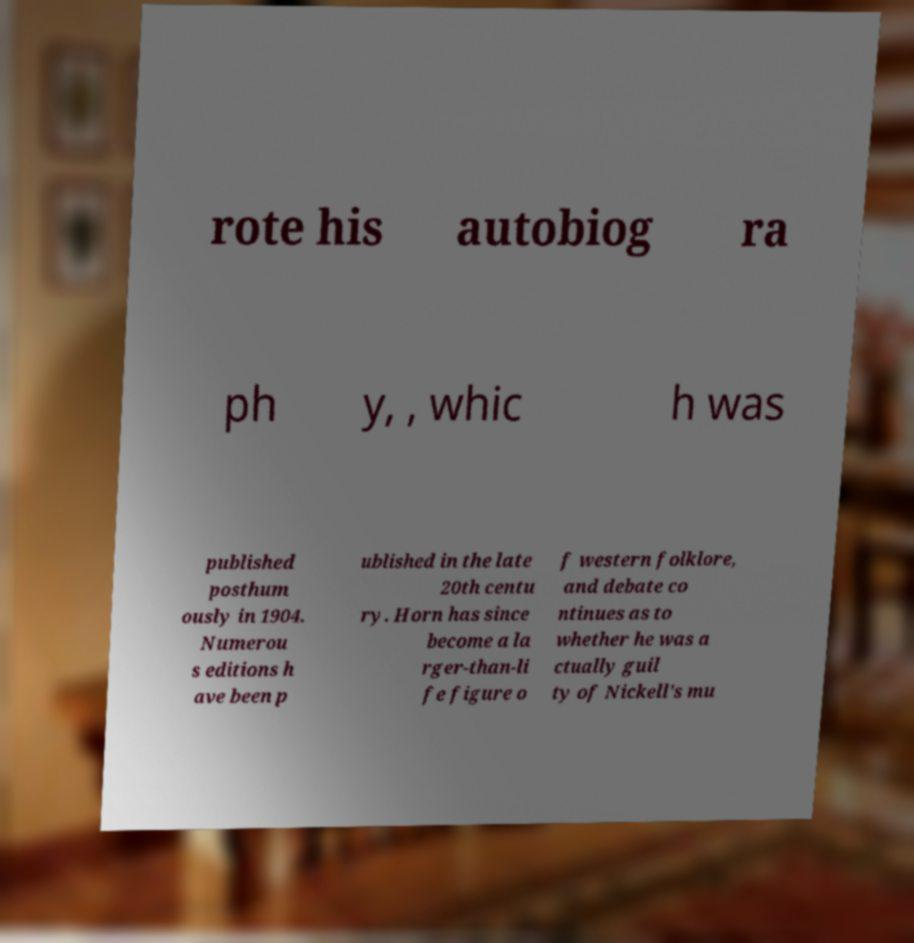Can you accurately transcribe the text from the provided image for me? rote his autobiog ra ph y, , whic h was published posthum ously in 1904. Numerou s editions h ave been p ublished in the late 20th centu ry. Horn has since become a la rger-than-li fe figure o f western folklore, and debate co ntinues as to whether he was a ctually guil ty of Nickell's mu 